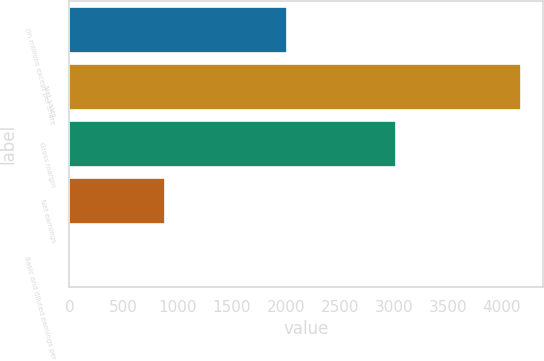<chart> <loc_0><loc_0><loc_500><loc_500><bar_chart><fcel>(in millions except per share<fcel>Net sales<fcel>Gross margin<fcel>Net earnings<fcel>Basic and diluted earnings per<nl><fcel>2012<fcel>4173<fcel>3017<fcel>883<fcel>0.56<nl></chart> 